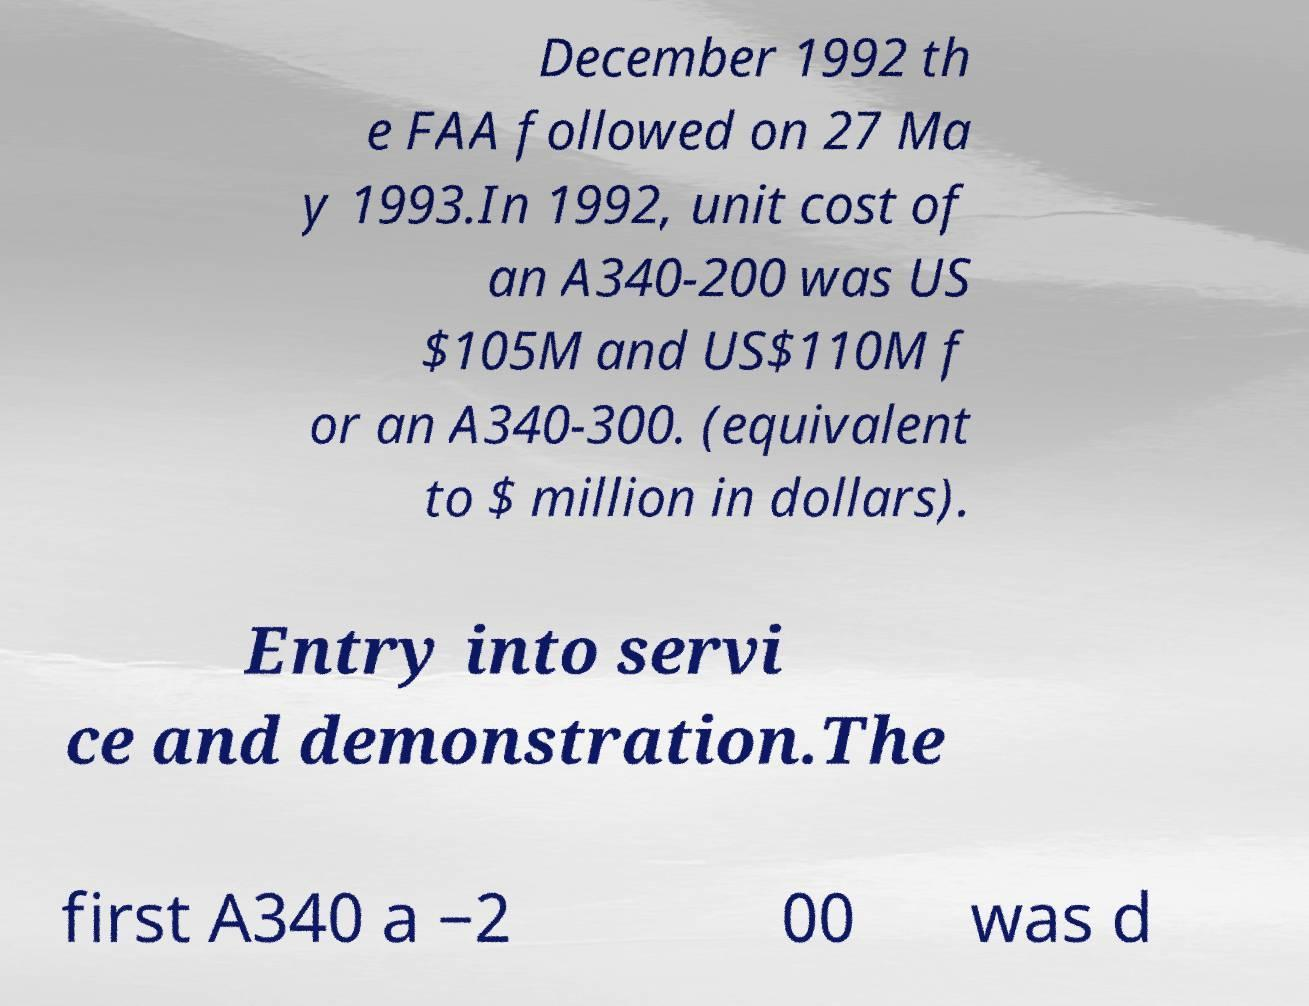Could you assist in decoding the text presented in this image and type it out clearly? December 1992 th e FAA followed on 27 Ma y 1993.In 1992, unit cost of an A340-200 was US $105M and US$110M f or an A340-300. (equivalent to $ million in dollars). Entry into servi ce and demonstration.The first A340 a −2 00 was d 